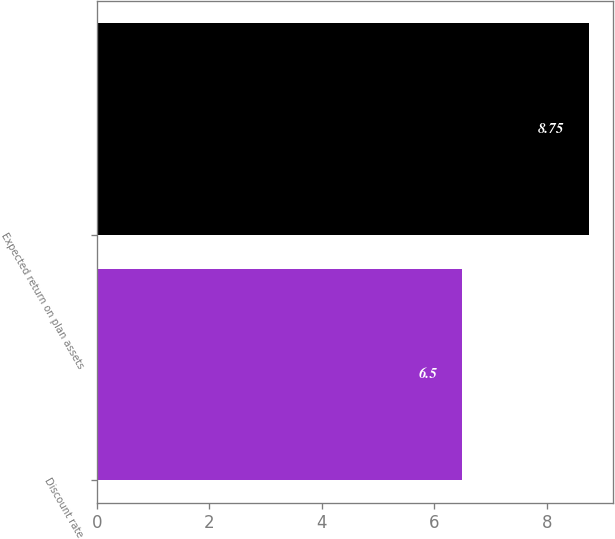<chart> <loc_0><loc_0><loc_500><loc_500><bar_chart><fcel>Discount rate<fcel>Expected return on plan assets<nl><fcel>6.5<fcel>8.75<nl></chart> 